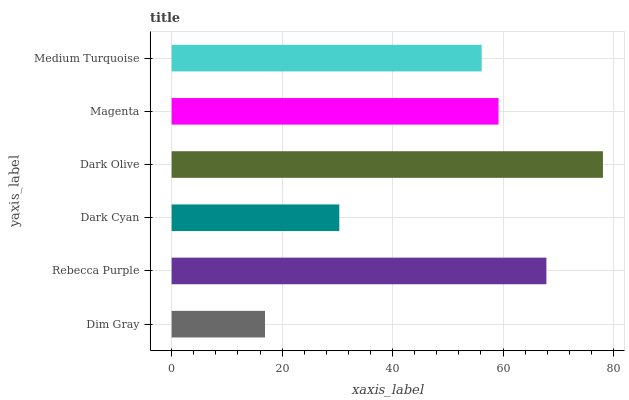Is Dim Gray the minimum?
Answer yes or no. Yes. Is Dark Olive the maximum?
Answer yes or no. Yes. Is Rebecca Purple the minimum?
Answer yes or no. No. Is Rebecca Purple the maximum?
Answer yes or no. No. Is Rebecca Purple greater than Dim Gray?
Answer yes or no. Yes. Is Dim Gray less than Rebecca Purple?
Answer yes or no. Yes. Is Dim Gray greater than Rebecca Purple?
Answer yes or no. No. Is Rebecca Purple less than Dim Gray?
Answer yes or no. No. Is Magenta the high median?
Answer yes or no. Yes. Is Medium Turquoise the low median?
Answer yes or no. Yes. Is Medium Turquoise the high median?
Answer yes or no. No. Is Dark Cyan the low median?
Answer yes or no. No. 